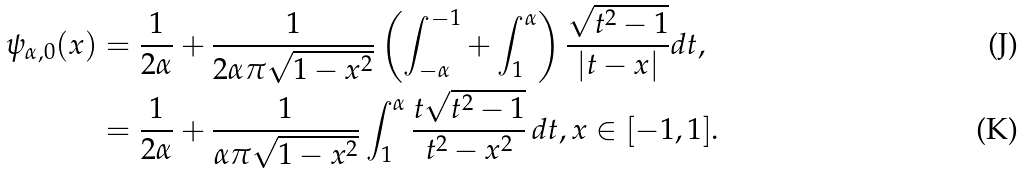Convert formula to latex. <formula><loc_0><loc_0><loc_500><loc_500>\psi _ { \alpha , 0 } ( x ) & = \frac { 1 } { 2 \alpha } + \frac { 1 } { 2 \alpha \pi \sqrt { 1 - x ^ { 2 } } } \left ( \int _ { - \alpha } ^ { - 1 } + \int _ { 1 } ^ { \alpha } \right ) \frac { \sqrt { t ^ { 2 } - 1 } } { | t - x | } d t , \\ & = \frac { 1 } { 2 \alpha } + \frac { 1 } { \alpha \pi \sqrt { 1 - x ^ { 2 } } } \int _ { 1 } ^ { \alpha } \frac { t \sqrt { t ^ { 2 } - 1 } } { t ^ { 2 } - x ^ { 2 } } \, d t , x \in [ - 1 , 1 ] .</formula> 